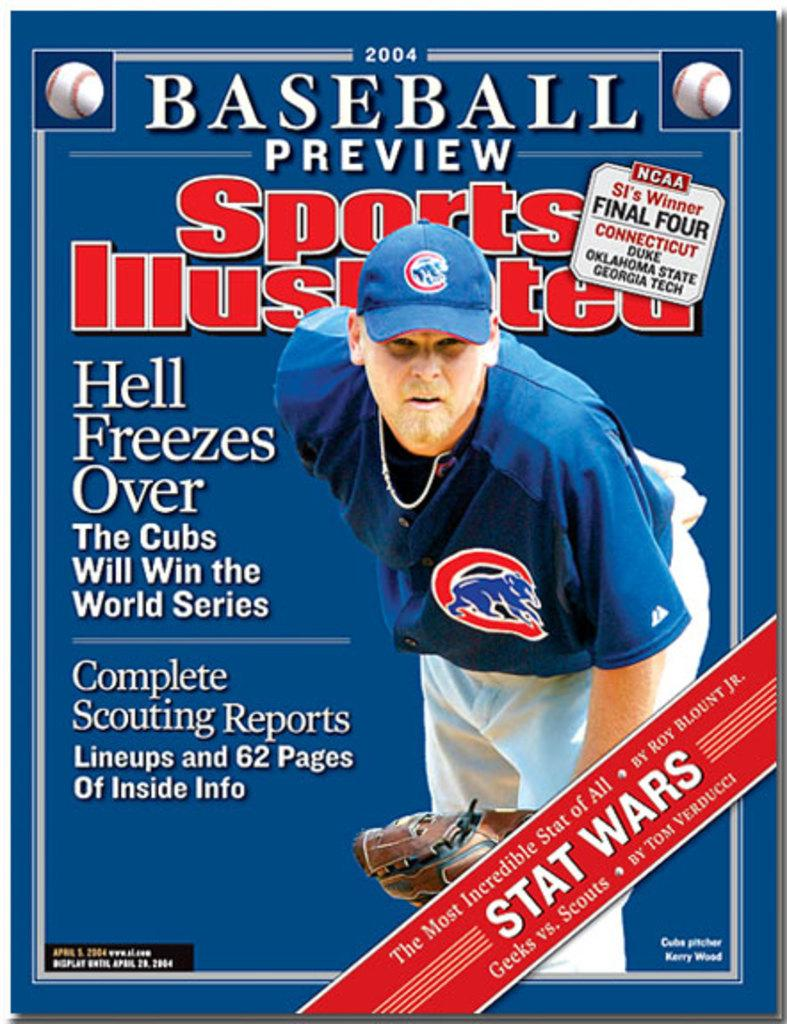<image>
Relay a brief, clear account of the picture shown. A sports illustrated magazine cover with the headline Hell Freezes Over. 